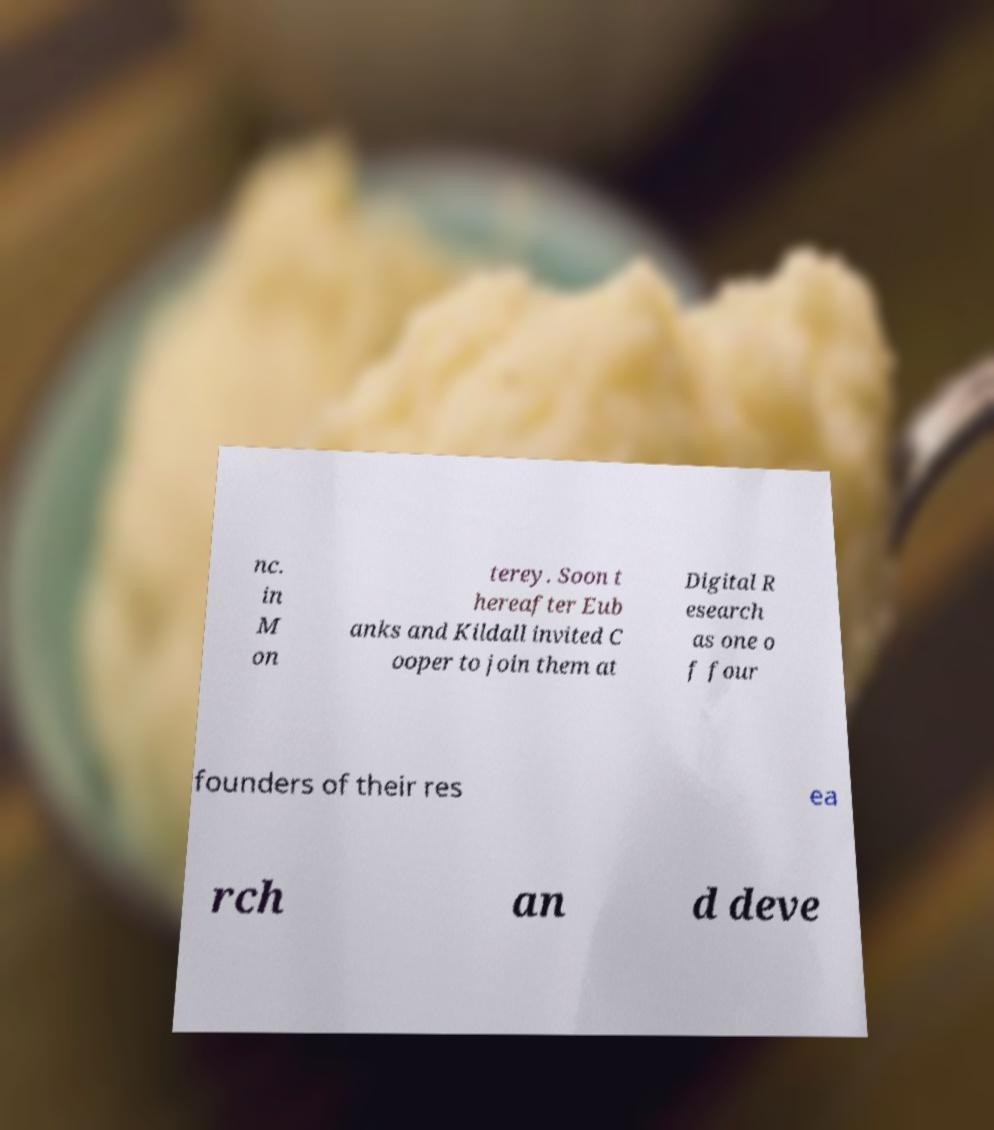Could you extract and type out the text from this image? nc. in M on terey. Soon t hereafter Eub anks and Kildall invited C ooper to join them at Digital R esearch as one o f four founders of their res ea rch an d deve 